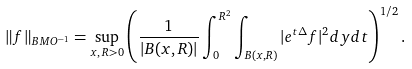<formula> <loc_0><loc_0><loc_500><loc_500>\| f \| _ { B M O ^ { - 1 } } = \sup _ { x , \, R > 0 } \left ( \frac { 1 } { | B ( x , R ) | } \int _ { 0 } ^ { R ^ { 2 } } \int _ { B ( x , R ) } | e ^ { t \Delta } f | ^ { 2 } d y d t \right ) ^ { 1 / 2 } .</formula> 